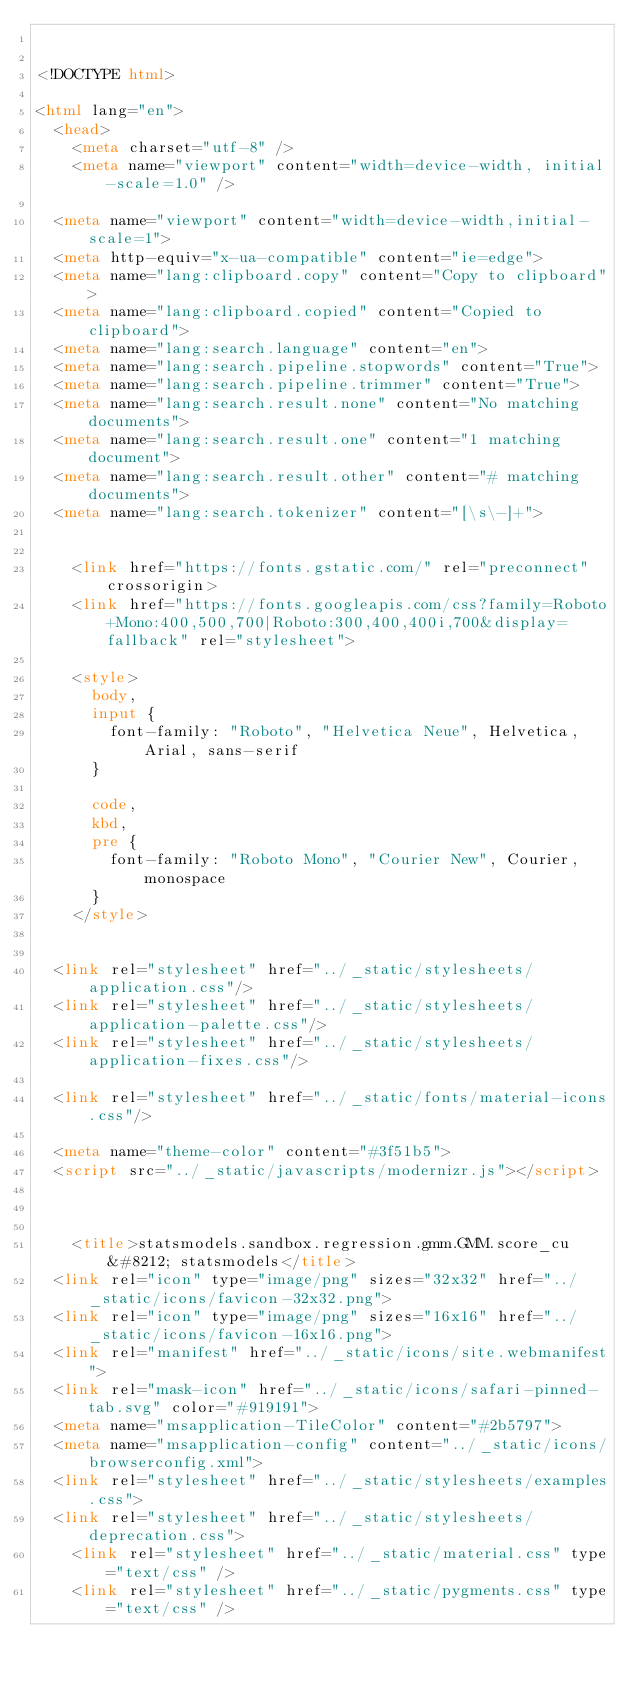Convert code to text. <code><loc_0><loc_0><loc_500><loc_500><_HTML_>

<!DOCTYPE html>

<html lang="en">
  <head>
    <meta charset="utf-8" />
    <meta name="viewport" content="width=device-width, initial-scale=1.0" />
  
  <meta name="viewport" content="width=device-width,initial-scale=1">
  <meta http-equiv="x-ua-compatible" content="ie=edge">
  <meta name="lang:clipboard.copy" content="Copy to clipboard">
  <meta name="lang:clipboard.copied" content="Copied to clipboard">
  <meta name="lang:search.language" content="en">
  <meta name="lang:search.pipeline.stopwords" content="True">
  <meta name="lang:search.pipeline.trimmer" content="True">
  <meta name="lang:search.result.none" content="No matching documents">
  <meta name="lang:search.result.one" content="1 matching document">
  <meta name="lang:search.result.other" content="# matching documents">
  <meta name="lang:search.tokenizer" content="[\s\-]+">

  
    <link href="https://fonts.gstatic.com/" rel="preconnect" crossorigin>
    <link href="https://fonts.googleapis.com/css?family=Roboto+Mono:400,500,700|Roboto:300,400,400i,700&display=fallback" rel="stylesheet">

    <style>
      body,
      input {
        font-family: "Roboto", "Helvetica Neue", Helvetica, Arial, sans-serif
      }

      code,
      kbd,
      pre {
        font-family: "Roboto Mono", "Courier New", Courier, monospace
      }
    </style>
  

  <link rel="stylesheet" href="../_static/stylesheets/application.css"/>
  <link rel="stylesheet" href="../_static/stylesheets/application-palette.css"/>
  <link rel="stylesheet" href="../_static/stylesheets/application-fixes.css"/>
  
  <link rel="stylesheet" href="../_static/fonts/material-icons.css"/>
  
  <meta name="theme-color" content="#3f51b5">
  <script src="../_static/javascripts/modernizr.js"></script>
  
  
  
    <title>statsmodels.sandbox.regression.gmm.GMM.score_cu &#8212; statsmodels</title>
  <link rel="icon" type="image/png" sizes="32x32" href="../_static/icons/favicon-32x32.png">
  <link rel="icon" type="image/png" sizes="16x16" href="../_static/icons/favicon-16x16.png">
  <link rel="manifest" href="../_static/icons/site.webmanifest">
  <link rel="mask-icon" href="../_static/icons/safari-pinned-tab.svg" color="#919191">
  <meta name="msapplication-TileColor" content="#2b5797">
  <meta name="msapplication-config" content="../_static/icons/browserconfig.xml">
  <link rel="stylesheet" href="../_static/stylesheets/examples.css">
  <link rel="stylesheet" href="../_static/stylesheets/deprecation.css">
    <link rel="stylesheet" href="../_static/material.css" type="text/css" />
    <link rel="stylesheet" href="../_static/pygments.css" type="text/css" /></code> 